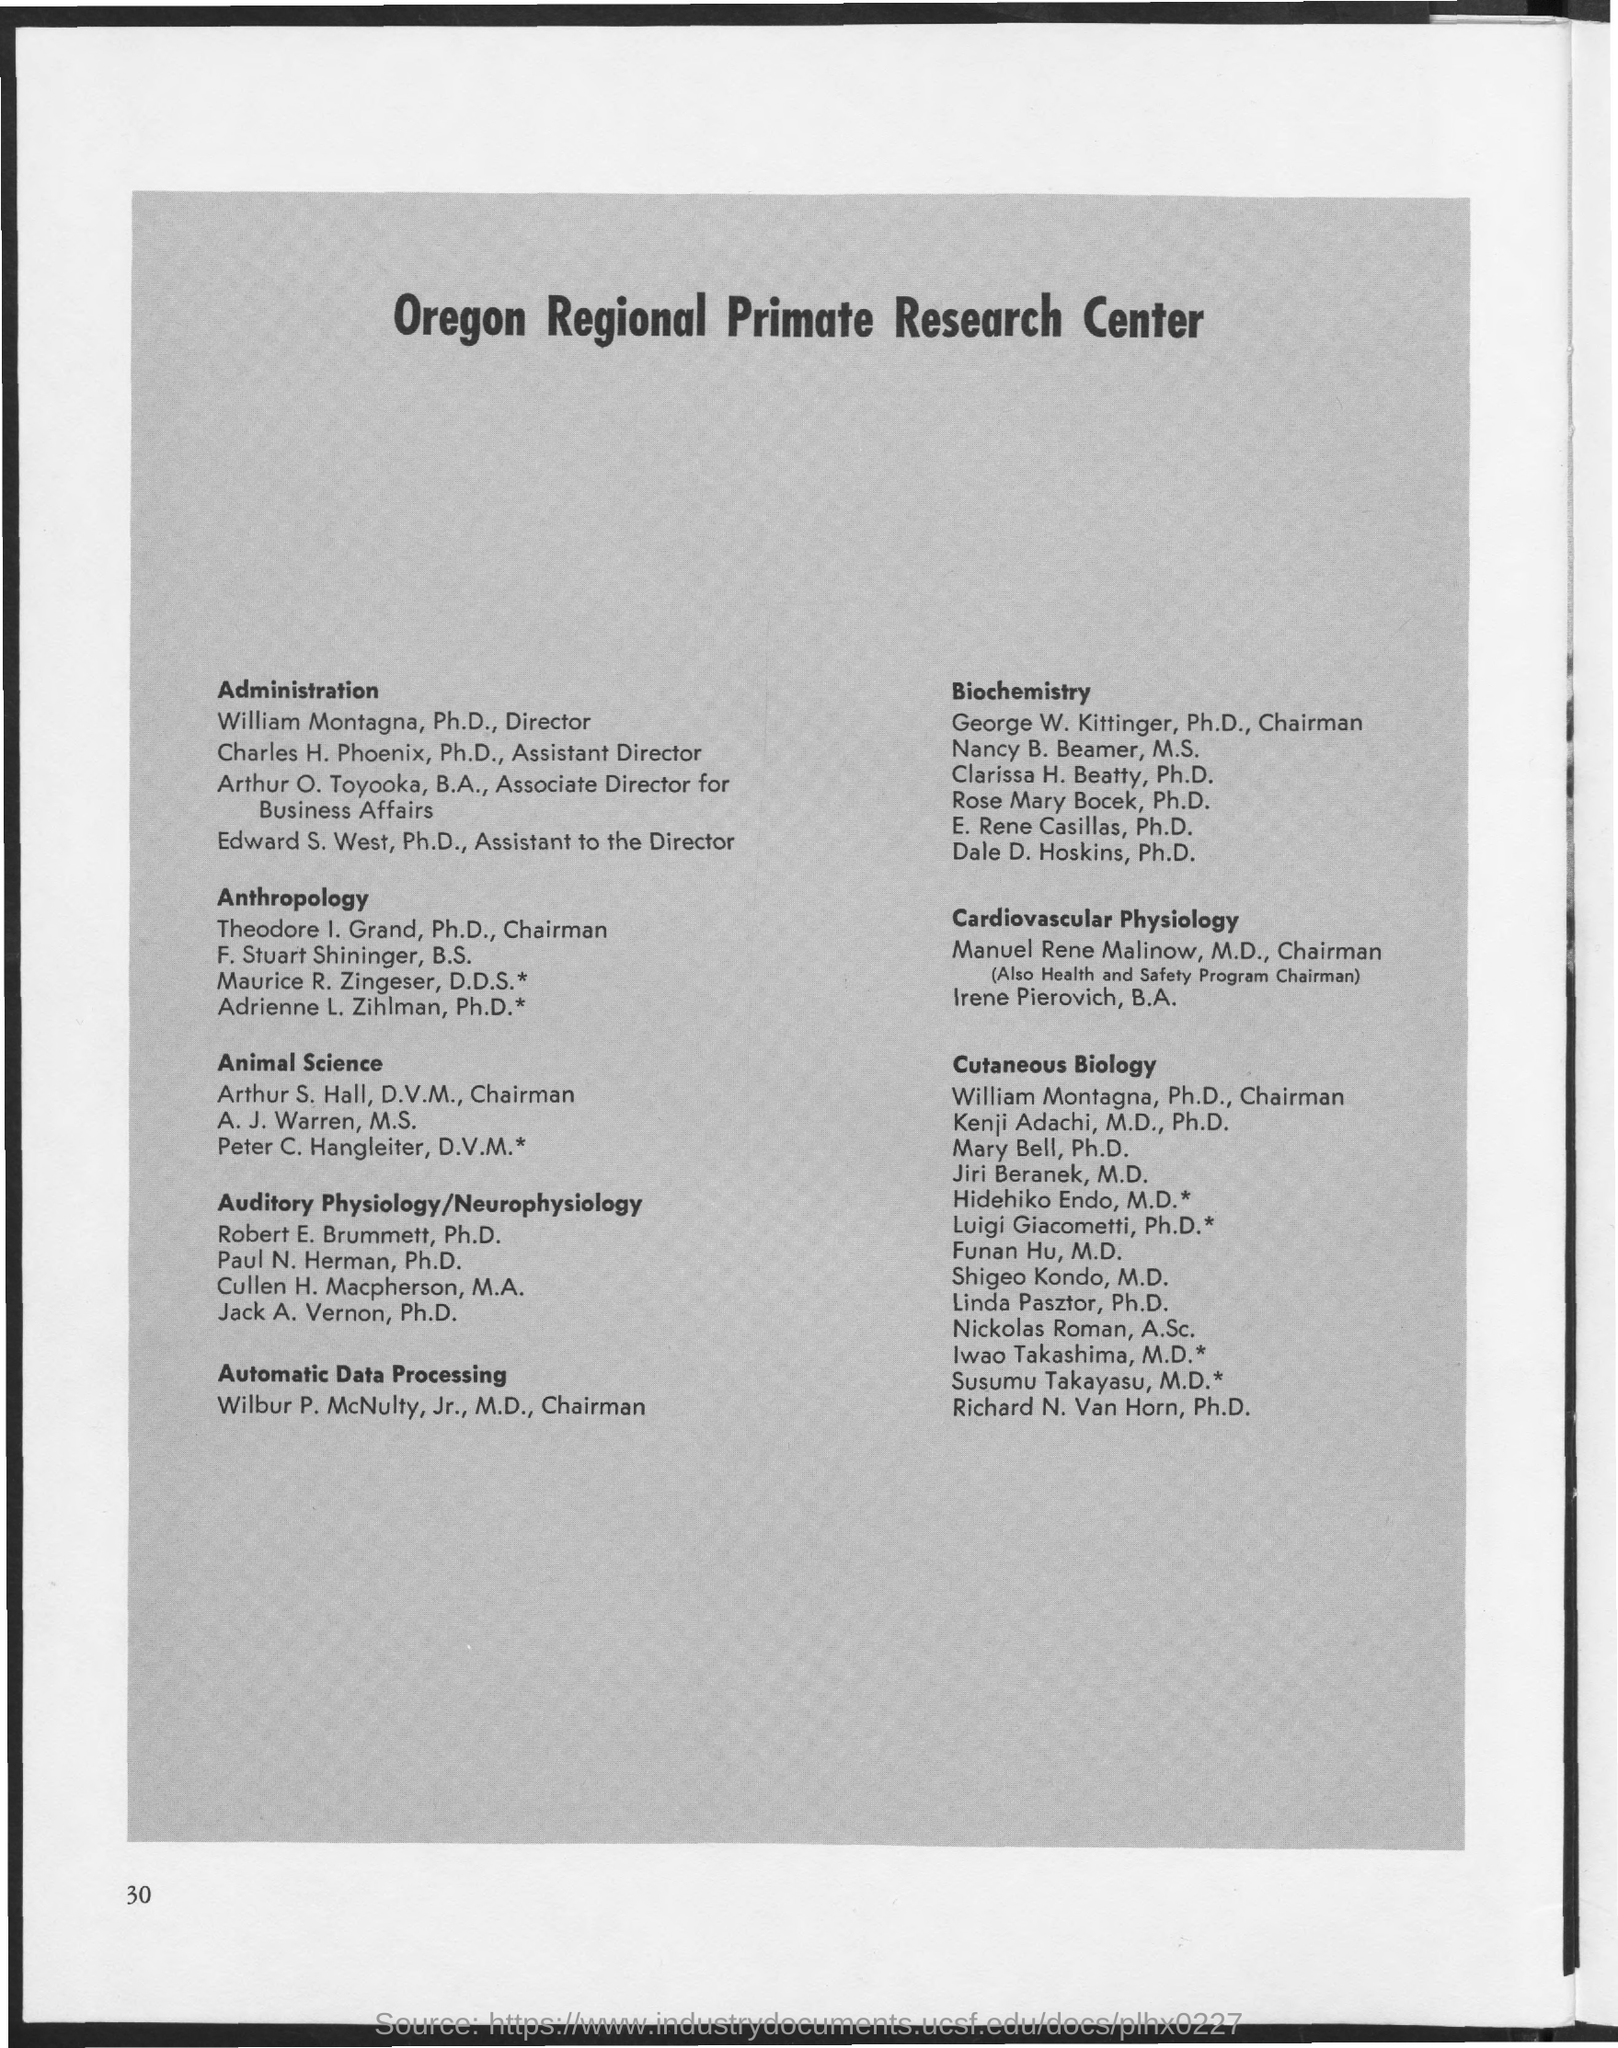What is the Page Number?
Your answer should be compact. 30. 